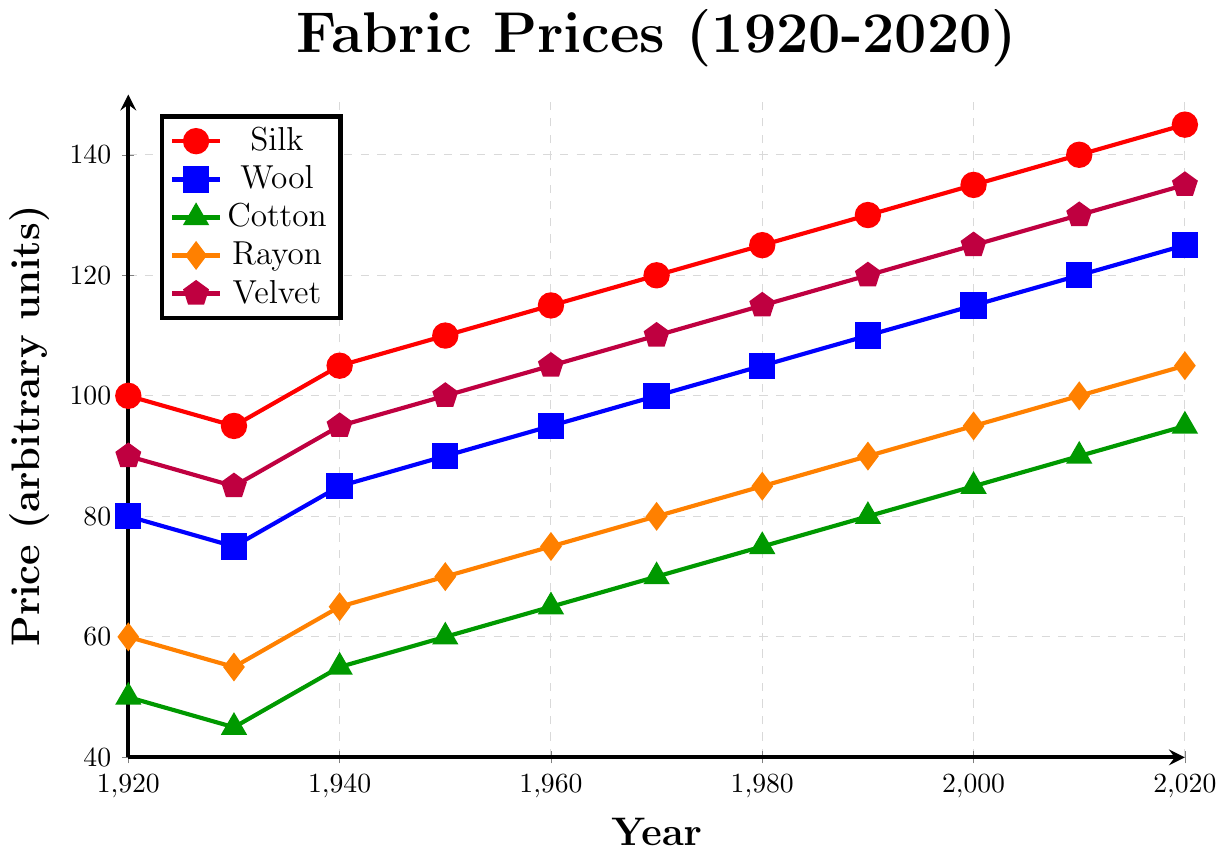What's the general trend for the price of Silk from 1920 to 2020? To determine the general trend, observe the progression of Silk prices over time. The price starts at 100 in 1920 and increases steadily until it reaches 145 in 2020. This consistent increase indicates an upward trend.
Answer: Upward trend Which fabric had the lowest price in 1930? Look at the data points for 1930 across all fabric lines. Wool is at 75, Cotton at 45, Silk at 95, Rayon at 55, and Velvet at 85. The lowest price among these is 45 for Cotton.
Answer: Cotton What is the difference in price between Wool and Rayon in 1970? Locate the prices for Wool and Rayon in 1970 from the chart. Wool is priced at 100 and Rayon at 80. The difference is calculated as 100 - 80 = 20.
Answer: 20 Which fabric experienced the highest increase in price from 1920 to 2020? Calculate the price increase for each fabric by subtracting their 1920 values from their 2020 values: Silk (145-100=45), Wool (125-80=45), Cotton (95-50=45), Rayon (105-60=45), Velvet (135-90=45). Since the increase is 45 for all fabrics, they all experienced the same increase in price.
Answer: All fabrics (Silk, Wool, Cotton, Rayon, Velvet) have the same increase In 1950, which fabric is priced closest to 100 units? Examine the chart for 1950 prices: Silk is 110, Wool is 90, Cotton is 60, Rayon is 70, Velvet is 100. Velvet is exactly at 100 units.
Answer: Velvet What's the average price of Rayon in the decades 1930, 1940, and 1950? Sum the prices of Rayon for the years 1930 (55), 1940 (65), and 1950 (70) and then divide by the number of years: (55 + 65 + 70) / 3 = 190 / 3 ≈ 63.33.
Answer: 63.33 Was there any year when the price of Cotton was higher than Wool? Compare the prices of Cotton and Wool for each year shown in the chart. In all years, the price of Cotton is always lower than that of Wool. Therefore, there is no year when Cotton was higher than Wool.
Answer: No Which fabric had the closest price to Silk in 1960? Check the prices for all fabrics in 1960. Silk is 115, Wool is 95, Cotton is 65, Rayon is 75, Velvet is 105. Velvet at 105 is the closest to Silk.
Answer: Velvet By how much more did the price of Velvet increase compared to Cotton between 1920 and 2020? Determine the price increase for both fabrics over these years: Velvet (135-90=45), Cotton (95-50=45). The difference in increases is 45 - 45 = 0.
Answer: 0 Between 1920 and 2020, which two fabrics have the most similar price trends? Observe the trendlines for all fabrics. Wool and Silk have nearly parallel trends as they both show a steady increase and their price difference remains relatively stable.
Answer: Wool and Silk 